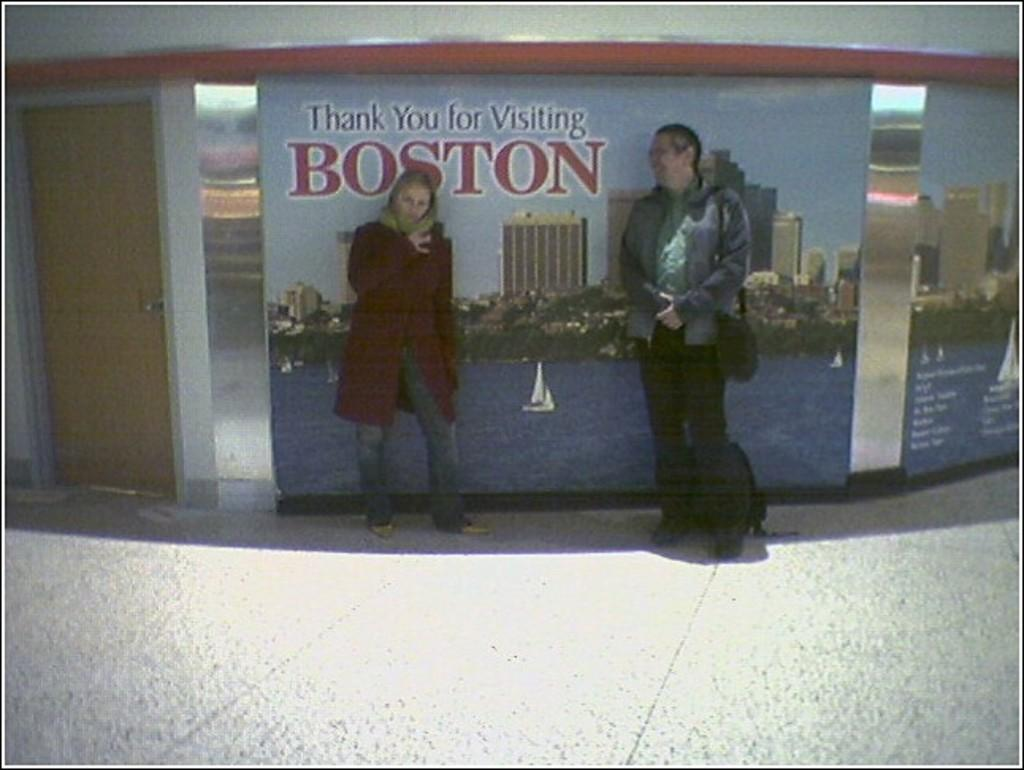How many people are in the image? There are two persons standing in the image. What can be seen on the wall in the image? There are boards on the wall. Is there any entrance or exit visible in the image? Yes, there is a door in the image. What type of rod can be seen in the image? There is no rod present in the image. What is the back of the door made of in the image? The provided facts do not mention the material of the door, so we cannot determine the back of the door's composition. 